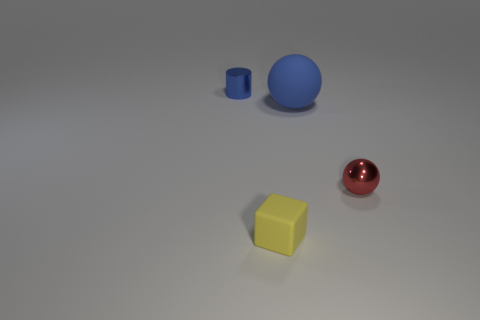There is a small thing right of the matte object in front of the ball in front of the big ball; what is it made of?
Your answer should be very brief. Metal. Are there any other things that have the same shape as the yellow rubber thing?
Ensure brevity in your answer.  No. The tiny metal object that is in front of the blue matte sphere is what color?
Provide a succinct answer. Red. What is the shape of the blue thing that is the same size as the yellow cube?
Offer a terse response. Cylinder. What number of blue objects are right of the small metal cylinder?
Your response must be concise. 1. How many objects are either yellow matte spheres or blue metallic cylinders?
Ensure brevity in your answer.  1. What shape is the tiny object that is on the left side of the red ball and in front of the cylinder?
Make the answer very short. Cube. How many yellow cylinders are there?
Make the answer very short. 0. The other small object that is the same material as the tiny red thing is what color?
Provide a short and direct response. Blue. Is the number of small red metallic objects greater than the number of tiny gray balls?
Make the answer very short. Yes. 